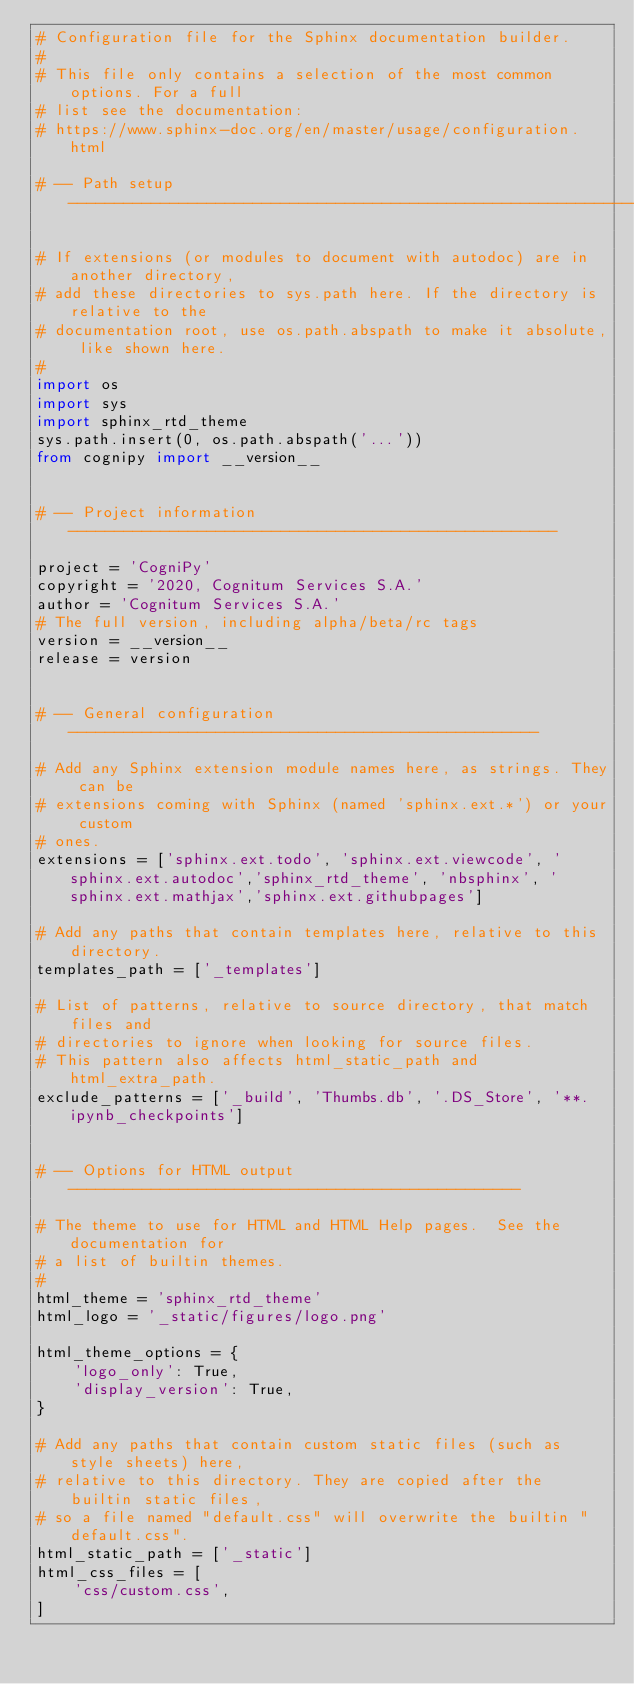<code> <loc_0><loc_0><loc_500><loc_500><_Python_># Configuration file for the Sphinx documentation builder.
#
# This file only contains a selection of the most common options. For a full
# list see the documentation:
# https://www.sphinx-doc.org/en/master/usage/configuration.html

# -- Path setup --------------------------------------------------------------

# If extensions (or modules to document with autodoc) are in another directory,
# add these directories to sys.path here. If the directory is relative to the
# documentation root, use os.path.abspath to make it absolute, like shown here.
#
import os
import sys
import sphinx_rtd_theme
sys.path.insert(0, os.path.abspath('...'))
from cognipy import __version__


# -- Project information -----------------------------------------------------

project = 'CogniPy'
copyright = '2020, Cognitum Services S.A.'
author = 'Cognitum Services S.A.'
# The full version, including alpha/beta/rc tags
version = __version__
release = version


# -- General configuration ---------------------------------------------------

# Add any Sphinx extension module names here, as strings. They can be
# extensions coming with Sphinx (named 'sphinx.ext.*') or your custom
# ones.
extensions = ['sphinx.ext.todo', 'sphinx.ext.viewcode', 'sphinx.ext.autodoc','sphinx_rtd_theme', 'nbsphinx', 'sphinx.ext.mathjax','sphinx.ext.githubpages']

# Add any paths that contain templates here, relative to this directory.
templates_path = ['_templates']

# List of patterns, relative to source directory, that match files and
# directories to ignore when looking for source files.
# This pattern also affects html_static_path and html_extra_path.
exclude_patterns = ['_build', 'Thumbs.db', '.DS_Store', '**.ipynb_checkpoints']


# -- Options for HTML output -------------------------------------------------

# The theme to use for HTML and HTML Help pages.  See the documentation for
# a list of builtin themes.
#
html_theme = 'sphinx_rtd_theme'
html_logo = '_static/figures/logo.png'

html_theme_options = {
    'logo_only': True,
    'display_version': True,
}

# Add any paths that contain custom static files (such as style sheets) here,
# relative to this directory. They are copied after the builtin static files,
# so a file named "default.css" will overwrite the builtin "default.css".
html_static_path = ['_static']
html_css_files = [
    'css/custom.css',
]
</code> 